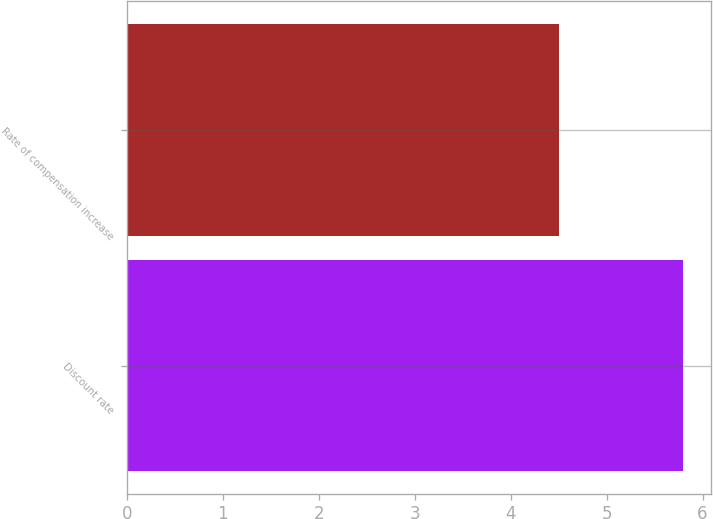<chart> <loc_0><loc_0><loc_500><loc_500><bar_chart><fcel>Discount rate<fcel>Rate of compensation increase<nl><fcel>5.8<fcel>4.5<nl></chart> 